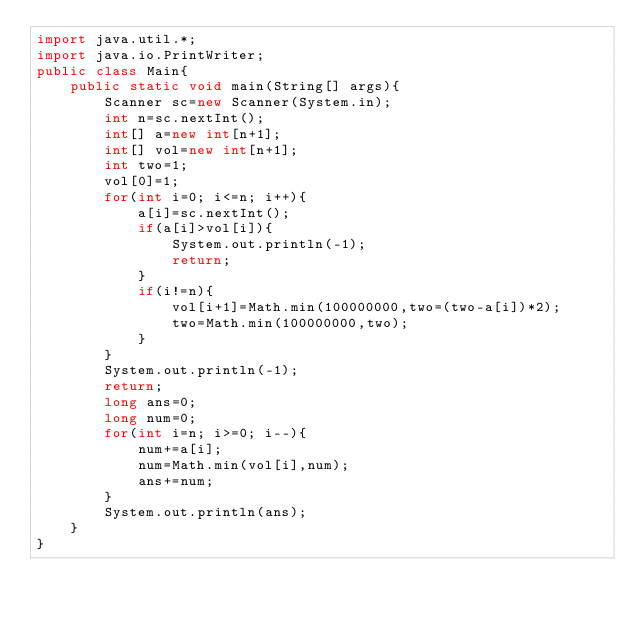<code> <loc_0><loc_0><loc_500><loc_500><_Java_>import java.util.*;
import java.io.PrintWriter;
public class Main{
	public static void main(String[] args){
		Scanner sc=new Scanner(System.in);
		int n=sc.nextInt();
		int[] a=new int[n+1];
		int[] vol=new int[n+1];
		int two=1;
		vol[0]=1;
		for(int i=0; i<=n; i++){
			a[i]=sc.nextInt();
			if(a[i]>vol[i]){
				System.out.println(-1);
				return;
			}
			if(i!=n){
				vol[i+1]=Math.min(100000000,two=(two-a[i])*2);
				two=Math.min(100000000,two);
			}
		}
		System.out.println(-1);
		return;
		long ans=0;
		long num=0;
		for(int i=n; i>=0; i--){
			num+=a[i];
			num=Math.min(vol[i],num);
			ans+=num;
		}
		System.out.println(ans);
	}
}
</code> 